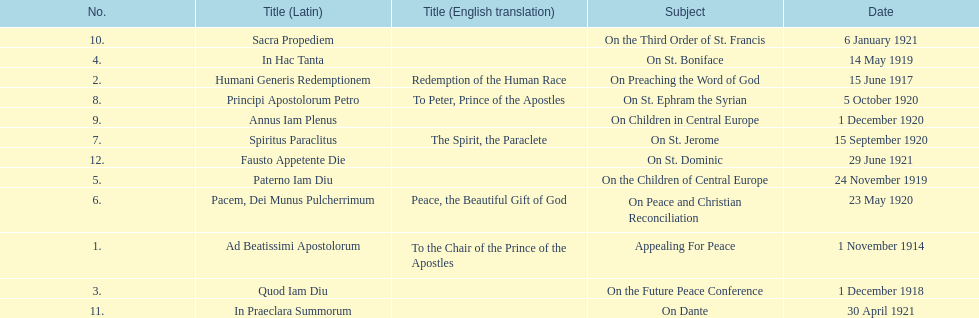What was the number of encyclopedias that had subjects relating specifically to children? 2. 